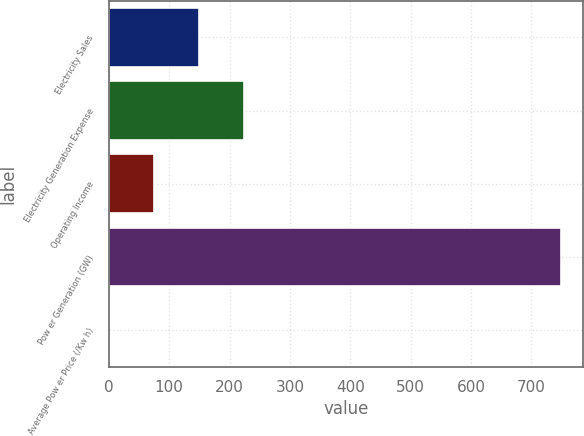Convert chart to OTSL. <chart><loc_0><loc_0><loc_500><loc_500><bar_chart><fcel>Electricity Sales<fcel>Electricity Generation Expense<fcel>Operating Income<fcel>Pow er Generation (GW)<fcel>Average Pow er Price (/Kw h)<nl><fcel>149.85<fcel>224.74<fcel>74.96<fcel>749<fcel>0.07<nl></chart> 